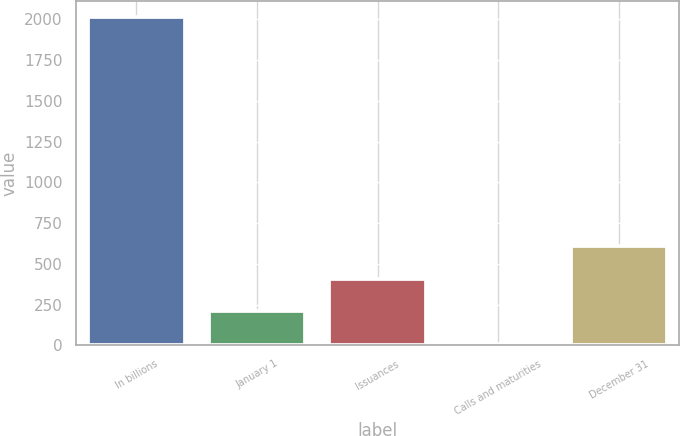Convert chart. <chart><loc_0><loc_0><loc_500><loc_500><bar_chart><fcel>In billions<fcel>January 1<fcel>Issuances<fcel>Calls and maturities<fcel>December 31<nl><fcel>2014<fcel>209.14<fcel>409.68<fcel>8.6<fcel>610.22<nl></chart> 